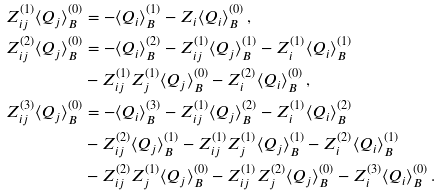<formula> <loc_0><loc_0><loc_500><loc_500>Z _ { i j } ^ { ( 1 ) } \langle Q _ { j } \rangle ^ { ( 0 ) } _ { B } & = - \langle Q _ { i } \rangle ^ { ( 1 ) } _ { B } - Z _ { i } \langle Q _ { i } \rangle ^ { ( 0 ) } _ { B } \, , \\ Z _ { i j } ^ { ( 2 ) } \langle Q _ { j } \rangle ^ { ( 0 ) } _ { B } & = - \langle Q _ { i } \rangle ^ { ( 2 ) } _ { B } - Z ^ { ( 1 ) } _ { i j } \langle Q _ { j } \rangle ^ { ( 1 ) } _ { B } - Z ^ { ( 1 ) } _ { i } \langle Q _ { i } \rangle ^ { ( 1 ) } _ { B } \\ & - Z ^ { ( 1 ) } _ { i j } Z ^ { ( 1 ) } _ { j } \langle Q _ { j } \rangle ^ { ( 0 ) } _ { B } - Z ^ { ( 2 ) } _ { i } \langle Q _ { i } \rangle ^ { ( 0 ) } _ { B } \, , \\ Z _ { i j } ^ { ( 3 ) } \langle Q _ { j } \rangle ^ { ( 0 ) } _ { B } & = - \langle Q _ { i } \rangle ^ { ( 3 ) } _ { B } - Z ^ { ( 1 ) } _ { i j } \langle Q _ { j } \rangle ^ { ( 2 ) } _ { B } - Z ^ { ( 1 ) } _ { i } \langle Q _ { i } \rangle ^ { ( 2 ) } _ { B } \\ & - Z ^ { ( 2 ) } _ { i j } \langle Q _ { j } \rangle ^ { ( 1 ) } _ { B } - Z ^ { ( 1 ) } _ { i j } Z ^ { ( 1 ) } _ { j } \langle Q _ { j } \rangle ^ { ( 1 ) } _ { B } - Z ^ { ( 2 ) } _ { i } \langle Q _ { i } \rangle ^ { ( 1 ) } _ { B } \\ & - Z ^ { ( 2 ) } _ { i j } Z ^ { ( 1 ) } _ { j } \langle Q _ { j } \rangle ^ { ( 0 ) } _ { B } - Z ^ { ( 1 ) } _ { i j } Z ^ { ( 2 ) } _ { j } \langle Q _ { j } \rangle ^ { ( 0 ) } _ { B } - Z ^ { ( 3 ) } _ { i } \langle Q _ { i } \rangle ^ { ( 0 ) } _ { B } \, .</formula> 